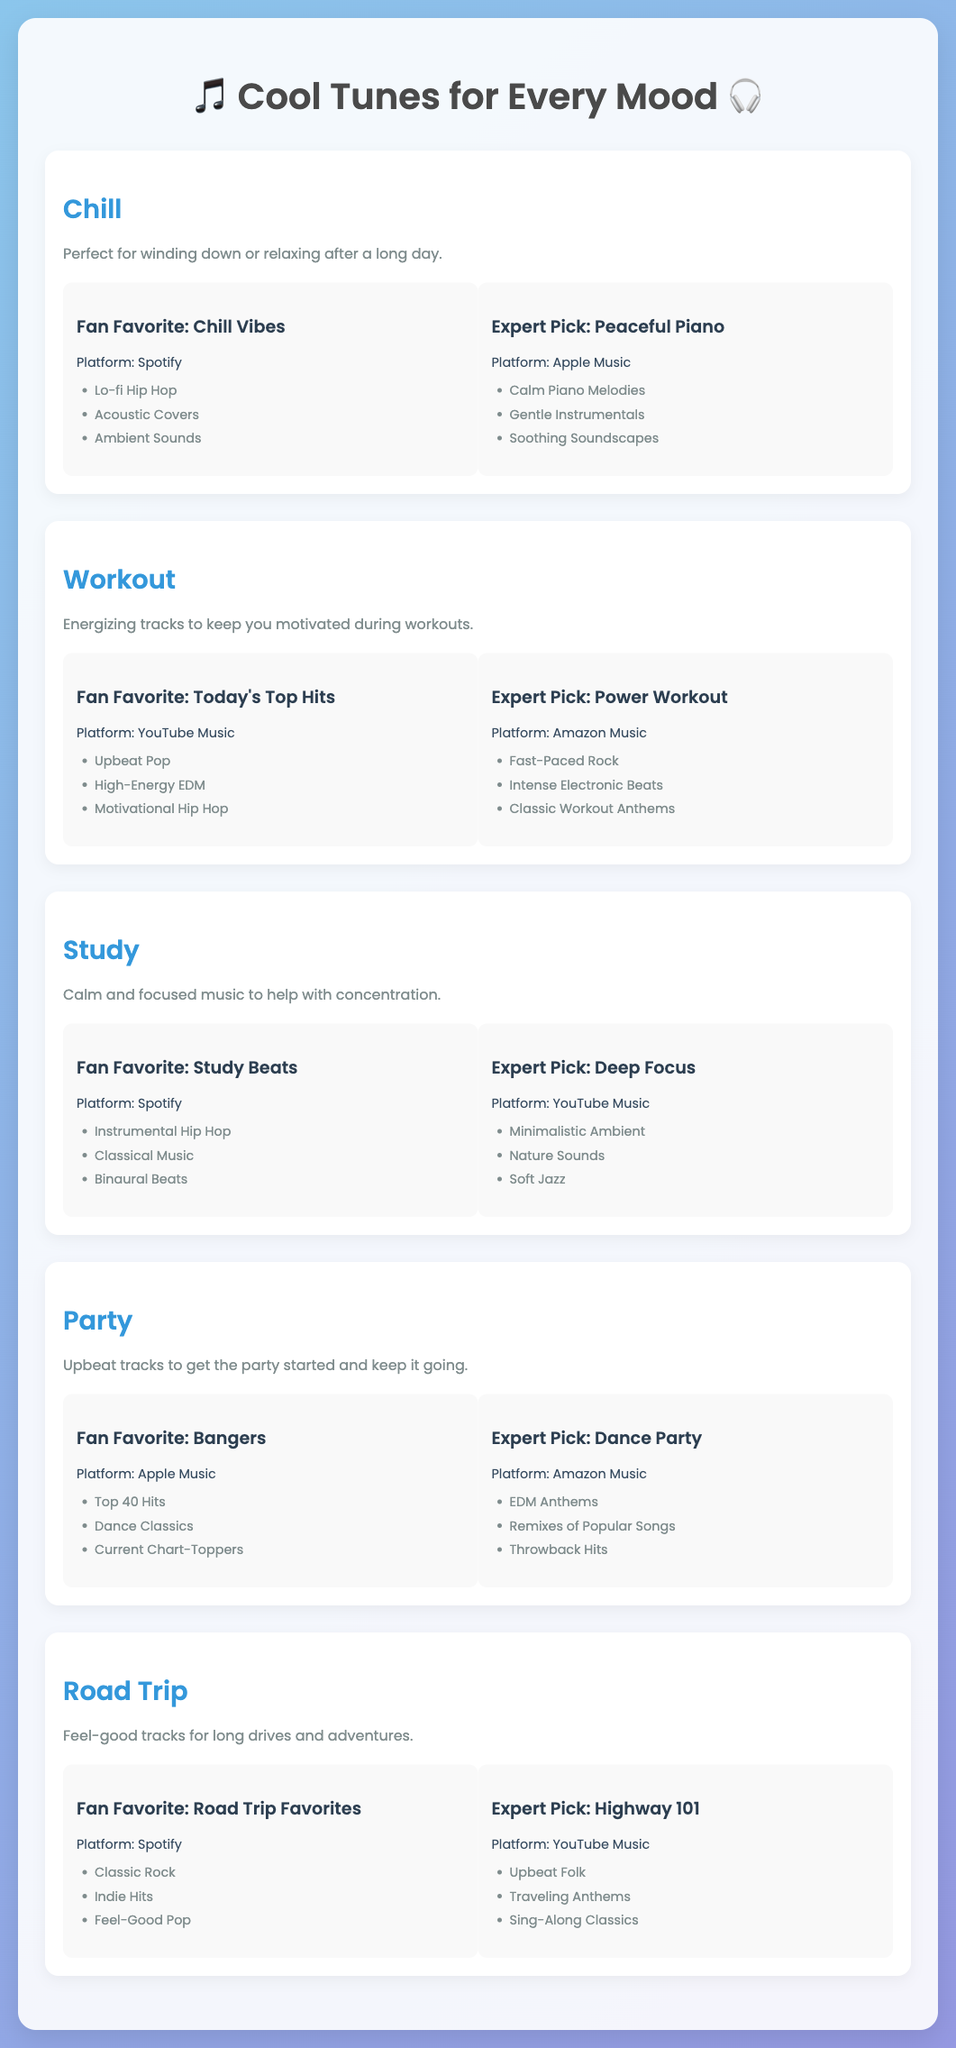What is the title of the document? The title is displayed prominently at the top of the document.
Answer: Cool Tunes for Every Mood What genre is recommended for relaxation? The document features a genre card specifically for winding down or relaxing.
Answer: Chill Which platform does the fan-favorite workout playlist belong to? Each playlist is associated with a specific platform mentioned alongside the title.
Answer: YouTube Music What is the expert pick for studying music? The expert recommendations are listed under each genre with titles.
Answer: Deep Focus What mood is the 'Bangers' playlist associated with? The mood is specified in the genre card related to the playlist.
Answer: Party How many playlists are under the Chill genre? Each genre has two playlists listed, so you can count them directly.
Answer: 2 Which song genre is part of the fan favorite 'Chill Vibes'? Each playlist has specific genres of music mentioned under it.
Answer: Lo-fi Hip Hop Which platform features the expert pick for a road trip? The platform is indicated next to the expert pick for the genre.
Answer: YouTube Music What is the primary purpose of the 'Workout' genre? The description under each genre explains its purpose.
Answer: Energizing tracks to keep you motivated during workouts 